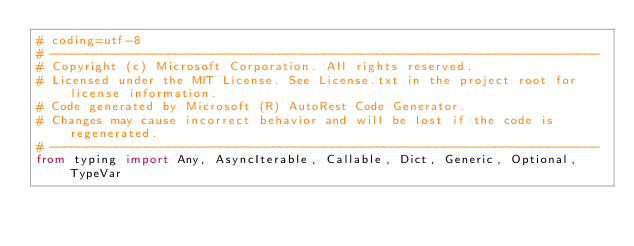<code> <loc_0><loc_0><loc_500><loc_500><_Python_># coding=utf-8
# --------------------------------------------------------------------------
# Copyright (c) Microsoft Corporation. All rights reserved.
# Licensed under the MIT License. See License.txt in the project root for license information.
# Code generated by Microsoft (R) AutoRest Code Generator.
# Changes may cause incorrect behavior and will be lost if the code is regenerated.
# --------------------------------------------------------------------------
from typing import Any, AsyncIterable, Callable, Dict, Generic, Optional, TypeVar</code> 